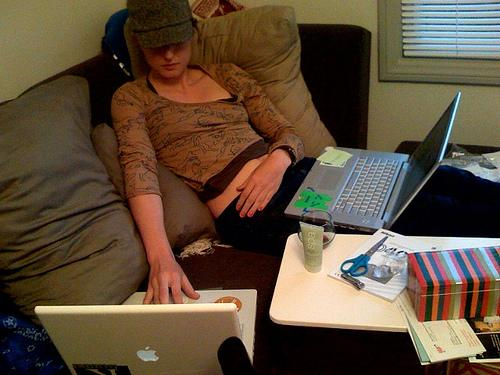What type of furniture can be observed in the image, and which objects are placed on it? A black table can be seen, upon which are two laptops, scissors, a striped box, a bottle of creme, a glass, and some documents. Mention the girl's outfit and the items she's wearing. The girl is wearing a patterned shirt with a brown shirt underneath, black pants, and a cap on her head. Enumerate three objects found on the table and their respective colors. Three objects on the table are blue scissors, a striped box of red, blue, and orange, and a bottle of creme with a glass containing liquid nearby. Tell me everything you can about the computers in the image, including their location and branding. There are two laptops: a silver Apple laptop on the girl's lap and a tan Apple laptop on the black table. Both have the Apple logo visible. Can you count the laptops present in the image and mention their brands? There are two laptops present, both of which are from the Apple brand. Determine any visible colors on the patterned piece of cloth on the sofa. A blue patterned piece of cloth can be seen on the sofa. Describe the girl's headwear and the location of her hands. The girl is wearing a cap on her head, her left hand is on her stomach, and her right hand is on the computer. What kind of document is located under the box, and what are the colors of the box? Some papers or documents are under a striped box, which is red, blue, and orange. Identify the object being held by the girl's left hand and the color of her nails. The girl's left hand is on her stomach, and her nails are painted red. Explain the objects and their interactions on the table. On the table, there are objects like scissors, a striped box, a bottle of creme, a glass with liquid, and documents. The objects don't seem to be interacting directly with one another. Which accessory is the girl wearing on her head? She is wearing a cap. Please provide a detailed description of the striped box in the image. The striped box has red, blue, and orange stripes and is placed on a table. What items are found beneath the colorful striped box? Answer: Which model of Apple laptop computer is shown in the image? The specific model is not identifiable from the image. Mention some features of the scene which indicate a casual, relaxed setting. The presence of two laptops in a casual setting, fluffy pillow on a sofa, and the girl's attire. What's placed underneath the striped box in the image? Documents are placed under the striped box. What is the color of the girl's nails? The girl's nails are painted red. Describe the girl's attire, specifically the clothing on her upper body. She is wearing a brown shirt under a patterned shirt. What type of accessory is near the girl's left hand? There is a bottle of cream near her left hand. What type of laptops are present in the image? Apple laptops Identify the accessories present on the table in the scene. Scissors, a tube of lotion, a striped box, and glasses with liquid. Describe the logo on the computer in detail. The logo is white and represents the Apple brand. How many caps are there in the image, and what is their location? There is one cap, and it is on the girl's head. Describe an element in the image that indicates a casual setting. Two laptop computers in a casual setting. What is the color of scissors found within the scene? The scissors are blue. What action is the girl doing with her left hand? She's placing her left hand on her stomach. What kind of liquid is inside the glasses on the table? The specific liquid is not identifiable from the image. Describe the appearance of the window in the image. The window has a wood frame and is covered by Venetian blinds. How many laptops are in the scene and where are they placed? There are two laptops, one on the girl's lap and another on the table. 